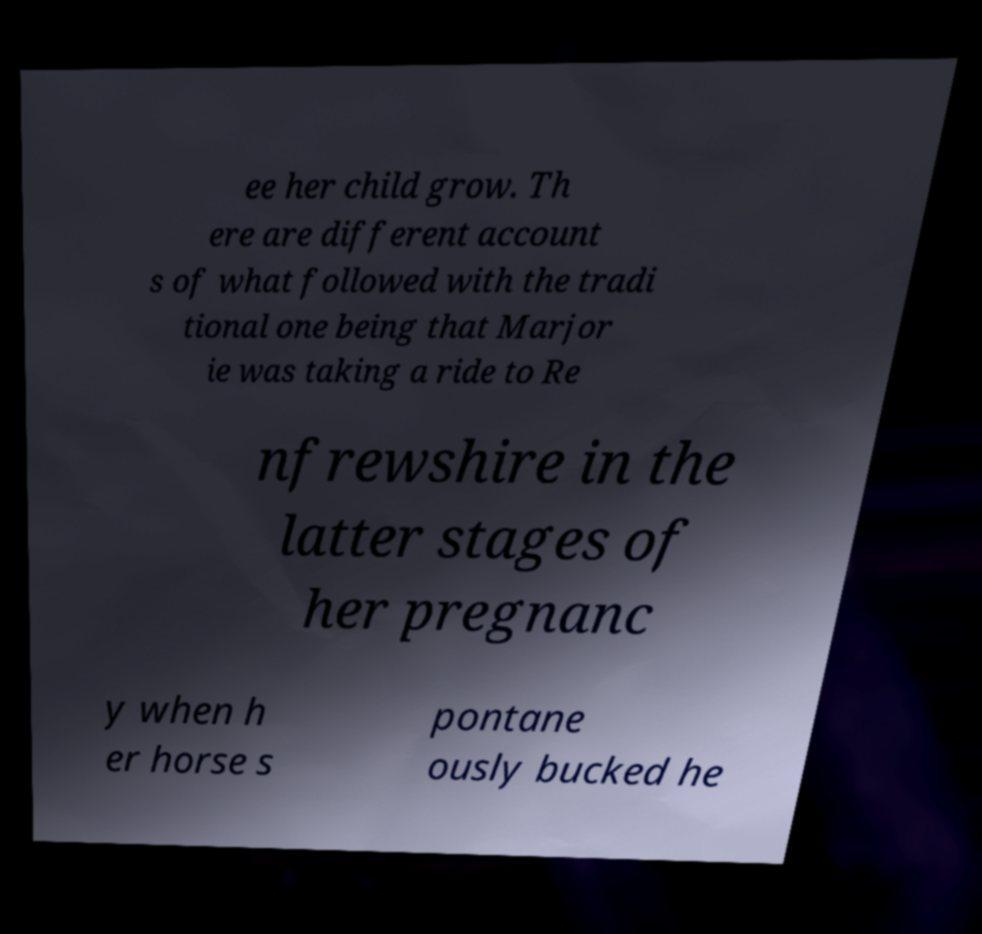For documentation purposes, I need the text within this image transcribed. Could you provide that? ee her child grow. Th ere are different account s of what followed with the tradi tional one being that Marjor ie was taking a ride to Re nfrewshire in the latter stages of her pregnanc y when h er horse s pontane ously bucked he 